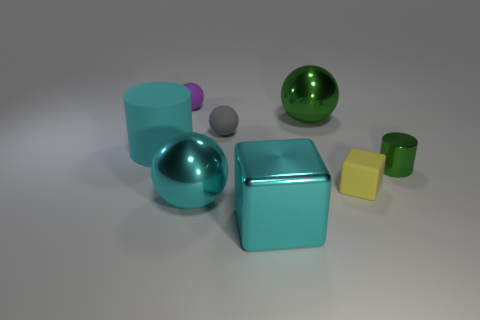Is the rubber cylinder the same color as the shiny block?
Your answer should be very brief. Yes. The metallic object that is the same shape as the cyan matte thing is what color?
Make the answer very short. Green. What is the material of the green thing that is in front of the large cyan cylinder that is behind the small cylinder?
Give a very brief answer. Metal. There is a green thing in front of the cyan rubber object; is it the same shape as the large cyan thing that is behind the small yellow thing?
Offer a terse response. Yes. What is the size of the metal object that is in front of the tiny yellow matte thing and on the right side of the large cyan sphere?
Offer a terse response. Large. How many other objects are the same color as the small metal cylinder?
Offer a very short reply. 1. Do the cyan thing that is behind the tiny yellow object and the yellow cube have the same material?
Your response must be concise. Yes. Is there any other thing that is the same size as the green shiny cylinder?
Give a very brief answer. Yes. Are there fewer purple rubber spheres that are in front of the small block than large cyan blocks right of the rubber cylinder?
Your response must be concise. Yes. Are there any other things that have the same shape as the tiny purple object?
Provide a short and direct response. Yes. 